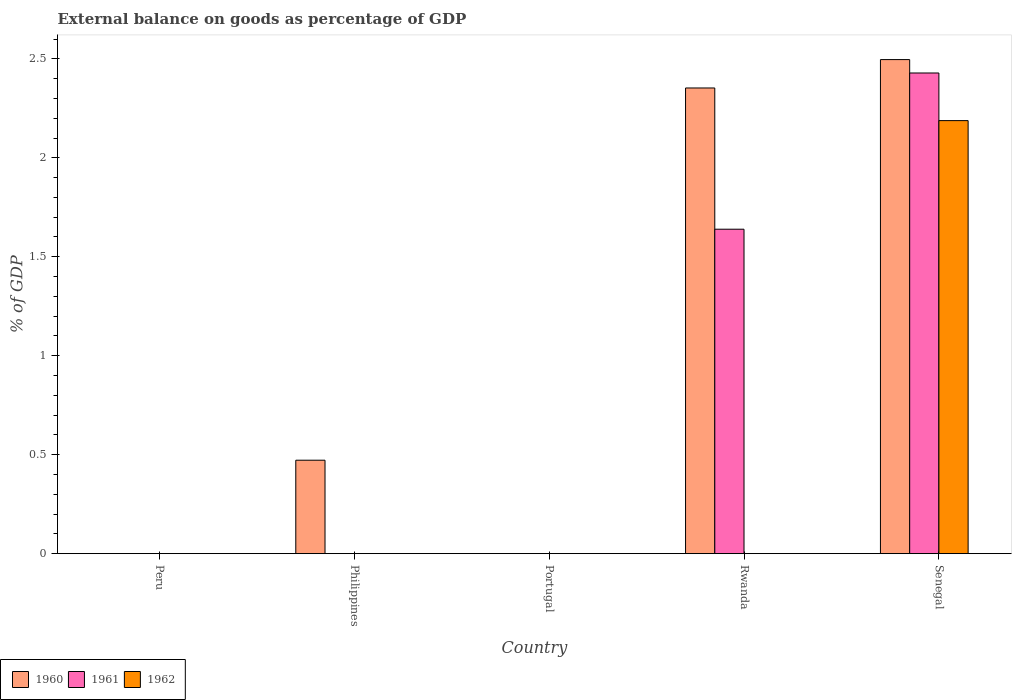How many different coloured bars are there?
Offer a very short reply. 3. Are the number of bars per tick equal to the number of legend labels?
Keep it short and to the point. No. How many bars are there on the 4th tick from the left?
Give a very brief answer. 2. What is the label of the 3rd group of bars from the left?
Make the answer very short. Portugal. Across all countries, what is the maximum external balance on goods as percentage of GDP in 1962?
Provide a succinct answer. 2.19. Across all countries, what is the minimum external balance on goods as percentage of GDP in 1960?
Your answer should be very brief. 0. In which country was the external balance on goods as percentage of GDP in 1962 maximum?
Keep it short and to the point. Senegal. What is the total external balance on goods as percentage of GDP in 1962 in the graph?
Provide a succinct answer. 2.19. What is the difference between the external balance on goods as percentage of GDP in 1960 in Philippines and that in Senegal?
Offer a terse response. -2.02. What is the difference between the external balance on goods as percentage of GDP in 1960 in Portugal and the external balance on goods as percentage of GDP in 1961 in Peru?
Keep it short and to the point. 0. What is the average external balance on goods as percentage of GDP in 1962 per country?
Provide a succinct answer. 0.44. What is the difference between the external balance on goods as percentage of GDP of/in 1961 and external balance on goods as percentage of GDP of/in 1960 in Senegal?
Give a very brief answer. -0.07. In how many countries, is the external balance on goods as percentage of GDP in 1961 greater than 1.1 %?
Your response must be concise. 2. What is the ratio of the external balance on goods as percentage of GDP in 1960 in Philippines to that in Rwanda?
Your answer should be compact. 0.2. What is the difference between the highest and the second highest external balance on goods as percentage of GDP in 1960?
Offer a very short reply. -2.02. What is the difference between the highest and the lowest external balance on goods as percentage of GDP in 1961?
Your answer should be very brief. 2.43. In how many countries, is the external balance on goods as percentage of GDP in 1961 greater than the average external balance on goods as percentage of GDP in 1961 taken over all countries?
Your answer should be compact. 2. Is it the case that in every country, the sum of the external balance on goods as percentage of GDP in 1961 and external balance on goods as percentage of GDP in 1960 is greater than the external balance on goods as percentage of GDP in 1962?
Offer a terse response. No. How many bars are there?
Make the answer very short. 6. How many countries are there in the graph?
Give a very brief answer. 5. Does the graph contain any zero values?
Make the answer very short. Yes. Where does the legend appear in the graph?
Offer a terse response. Bottom left. How many legend labels are there?
Provide a short and direct response. 3. How are the legend labels stacked?
Your answer should be compact. Horizontal. What is the title of the graph?
Your answer should be very brief. External balance on goods as percentage of GDP. Does "2003" appear as one of the legend labels in the graph?
Offer a very short reply. No. What is the label or title of the Y-axis?
Your answer should be compact. % of GDP. What is the % of GDP in 1960 in Peru?
Provide a short and direct response. 0. What is the % of GDP of 1960 in Philippines?
Your response must be concise. 0.47. What is the % of GDP in 1961 in Philippines?
Your response must be concise. 0. What is the % of GDP in 1962 in Philippines?
Offer a very short reply. 0. What is the % of GDP of 1960 in Portugal?
Offer a terse response. 0. What is the % of GDP of 1961 in Portugal?
Provide a short and direct response. 0. What is the % of GDP of 1962 in Portugal?
Give a very brief answer. 0. What is the % of GDP in 1960 in Rwanda?
Provide a succinct answer. 2.35. What is the % of GDP of 1961 in Rwanda?
Your answer should be compact. 1.64. What is the % of GDP in 1960 in Senegal?
Make the answer very short. 2.5. What is the % of GDP of 1961 in Senegal?
Your answer should be compact. 2.43. What is the % of GDP in 1962 in Senegal?
Offer a very short reply. 2.19. Across all countries, what is the maximum % of GDP in 1960?
Ensure brevity in your answer.  2.5. Across all countries, what is the maximum % of GDP in 1961?
Offer a very short reply. 2.43. Across all countries, what is the maximum % of GDP of 1962?
Your response must be concise. 2.19. Across all countries, what is the minimum % of GDP in 1960?
Provide a short and direct response. 0. Across all countries, what is the minimum % of GDP in 1961?
Your answer should be compact. 0. What is the total % of GDP of 1960 in the graph?
Provide a short and direct response. 5.32. What is the total % of GDP of 1961 in the graph?
Provide a short and direct response. 4.07. What is the total % of GDP in 1962 in the graph?
Offer a very short reply. 2.19. What is the difference between the % of GDP of 1960 in Philippines and that in Rwanda?
Ensure brevity in your answer.  -1.88. What is the difference between the % of GDP in 1960 in Philippines and that in Senegal?
Your answer should be very brief. -2.02. What is the difference between the % of GDP of 1960 in Rwanda and that in Senegal?
Provide a succinct answer. -0.14. What is the difference between the % of GDP in 1961 in Rwanda and that in Senegal?
Ensure brevity in your answer.  -0.79. What is the difference between the % of GDP of 1960 in Philippines and the % of GDP of 1961 in Rwanda?
Keep it short and to the point. -1.17. What is the difference between the % of GDP in 1960 in Philippines and the % of GDP in 1961 in Senegal?
Offer a terse response. -1.96. What is the difference between the % of GDP in 1960 in Philippines and the % of GDP in 1962 in Senegal?
Provide a succinct answer. -1.72. What is the difference between the % of GDP in 1960 in Rwanda and the % of GDP in 1961 in Senegal?
Make the answer very short. -0.08. What is the difference between the % of GDP in 1960 in Rwanda and the % of GDP in 1962 in Senegal?
Keep it short and to the point. 0.16. What is the difference between the % of GDP in 1961 in Rwanda and the % of GDP in 1962 in Senegal?
Offer a very short reply. -0.55. What is the average % of GDP of 1960 per country?
Provide a short and direct response. 1.06. What is the average % of GDP in 1961 per country?
Keep it short and to the point. 0.81. What is the average % of GDP of 1962 per country?
Keep it short and to the point. 0.44. What is the difference between the % of GDP in 1960 and % of GDP in 1961 in Rwanda?
Provide a short and direct response. 0.71. What is the difference between the % of GDP of 1960 and % of GDP of 1961 in Senegal?
Make the answer very short. 0.07. What is the difference between the % of GDP in 1960 and % of GDP in 1962 in Senegal?
Offer a terse response. 0.31. What is the difference between the % of GDP in 1961 and % of GDP in 1962 in Senegal?
Ensure brevity in your answer.  0.24. What is the ratio of the % of GDP of 1960 in Philippines to that in Rwanda?
Your response must be concise. 0.2. What is the ratio of the % of GDP of 1960 in Philippines to that in Senegal?
Make the answer very short. 0.19. What is the ratio of the % of GDP of 1960 in Rwanda to that in Senegal?
Provide a succinct answer. 0.94. What is the ratio of the % of GDP of 1961 in Rwanda to that in Senegal?
Give a very brief answer. 0.68. What is the difference between the highest and the second highest % of GDP in 1960?
Offer a very short reply. 0.14. What is the difference between the highest and the lowest % of GDP in 1960?
Keep it short and to the point. 2.5. What is the difference between the highest and the lowest % of GDP in 1961?
Your answer should be very brief. 2.43. What is the difference between the highest and the lowest % of GDP of 1962?
Your response must be concise. 2.19. 